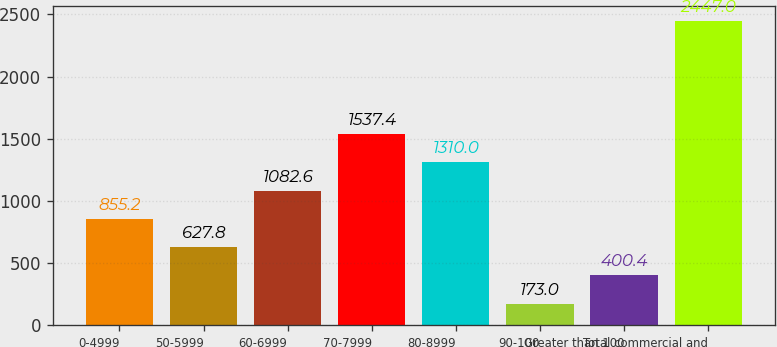Convert chart to OTSL. <chart><loc_0><loc_0><loc_500><loc_500><bar_chart><fcel>0-4999<fcel>50-5999<fcel>60-6999<fcel>70-7999<fcel>80-8999<fcel>90-100<fcel>Greater than 100<fcel>Total commercial and<nl><fcel>855.2<fcel>627.8<fcel>1082.6<fcel>1537.4<fcel>1310<fcel>173<fcel>400.4<fcel>2447<nl></chart> 